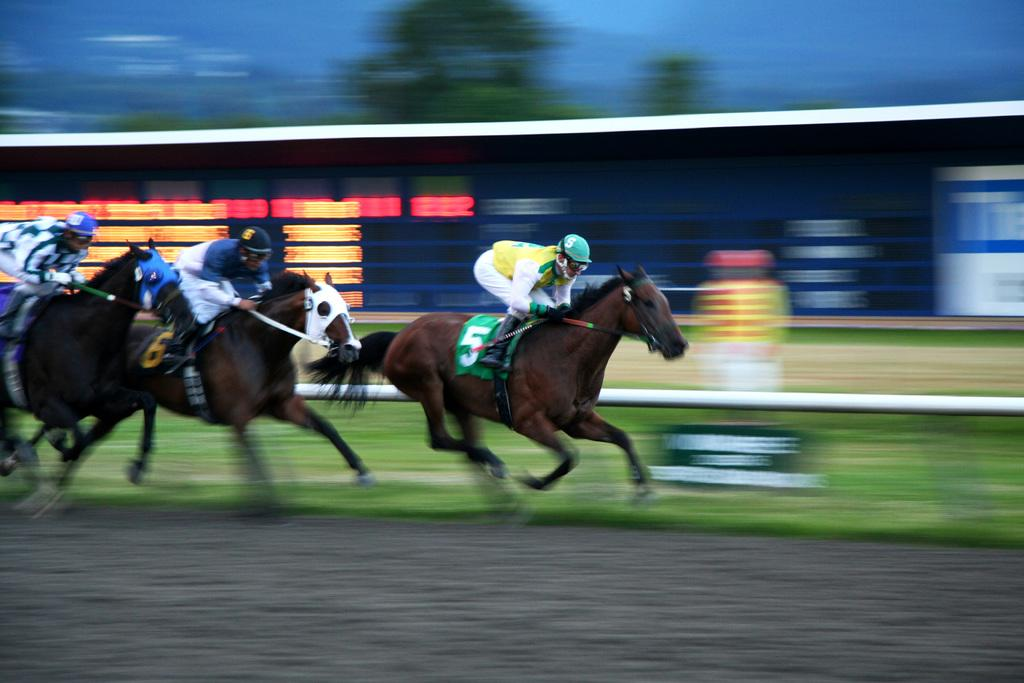What are the people in the image doing? The people in the image are riding horses. What safety equipment are the people wearing? The people are wearing helmets. What can be seen in the background of the image? There is a metal rod, grass, and trees visible in the background of the image. What type of voice can be heard coming from the police officer in the image? There is no police officer present in the image, so it's not possible to determine what type of voice might be heard. 